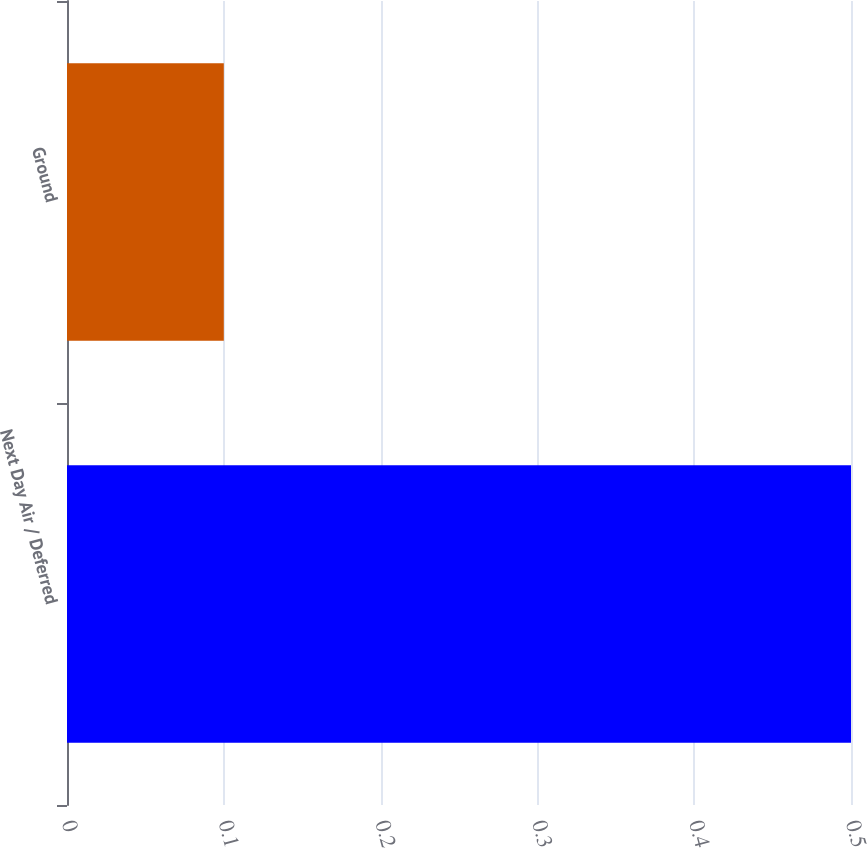Convert chart to OTSL. <chart><loc_0><loc_0><loc_500><loc_500><bar_chart><fcel>Next Day Air / Deferred<fcel>Ground<nl><fcel>0.5<fcel>0.1<nl></chart> 